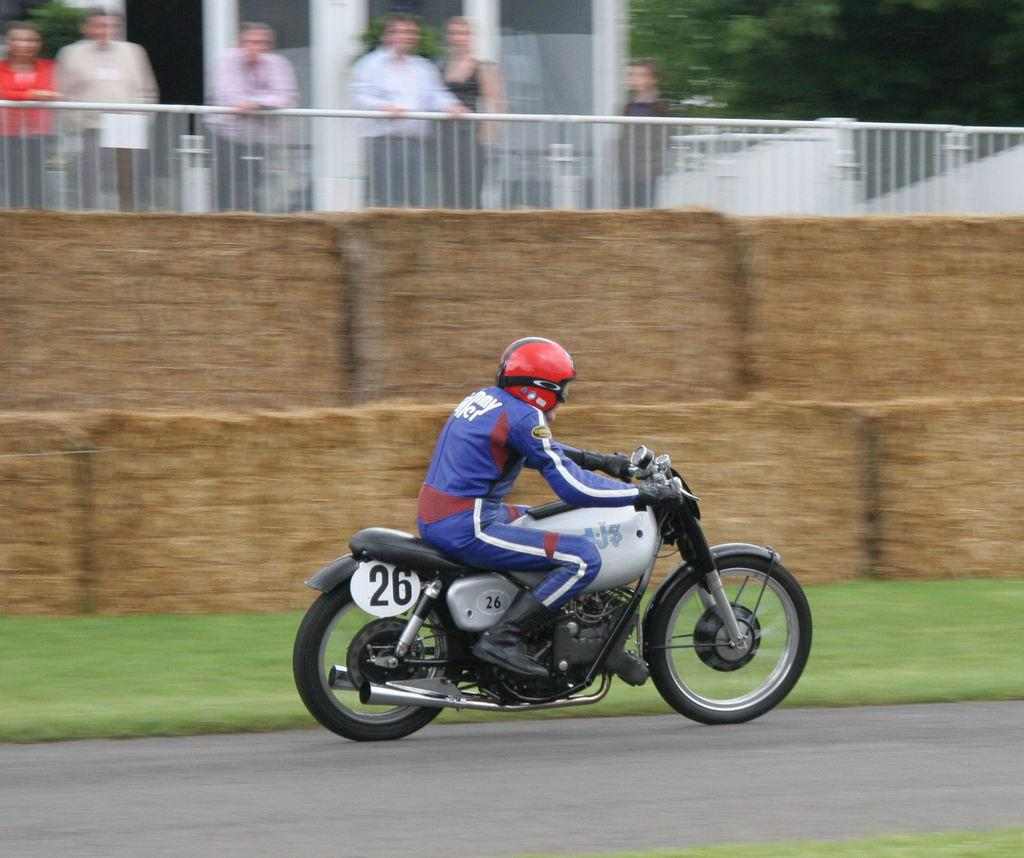What is the main subject of the image? There is a person in the image. What is the person doing in the image? The person is riding a motorcycle. What protective gear is the person wearing? The person is wearing a red helmet. Can you see a light bulb illuminating the person's path in the image? There is no light bulb present in the image. 